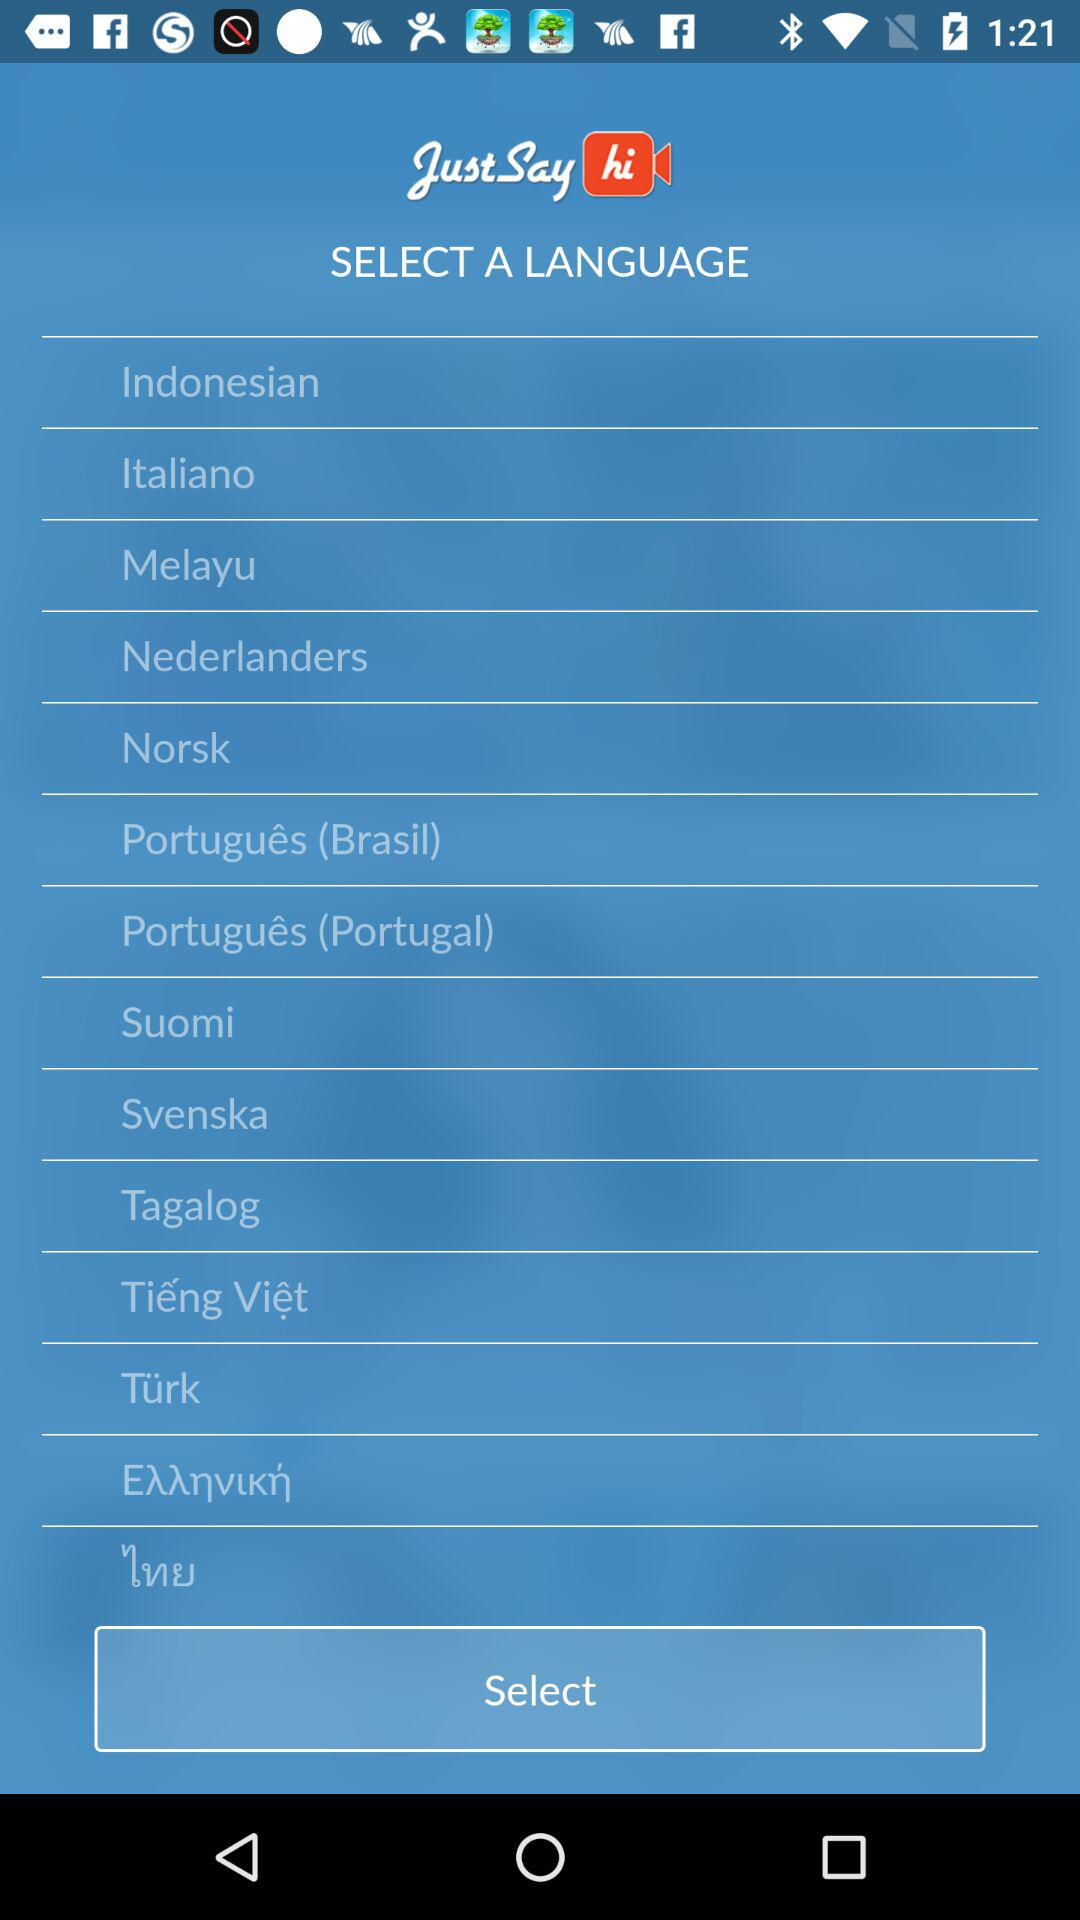What is the application name? The application name is "JustSay hi". 